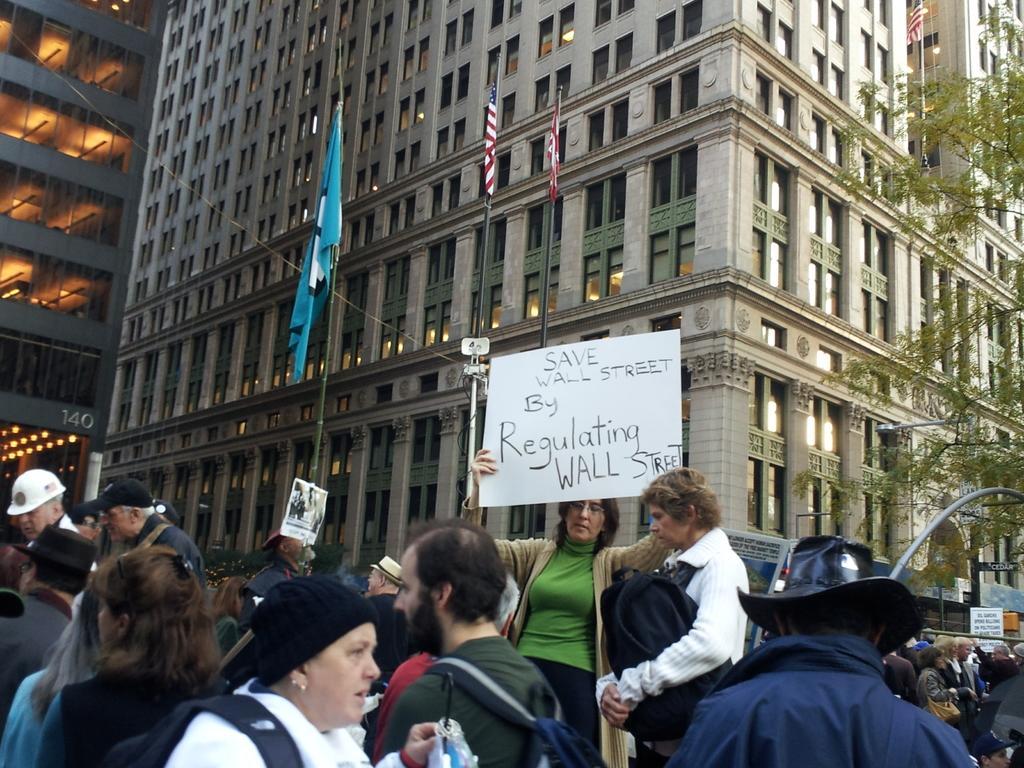In one or two sentences, can you explain what this image depicts? In the picture I can see the buildings and glass windows. I can see the flag poles. I can see a few people at the bottom of the picture. I can see a woman holding a white sheet with text on it. There are trees on the right side. 